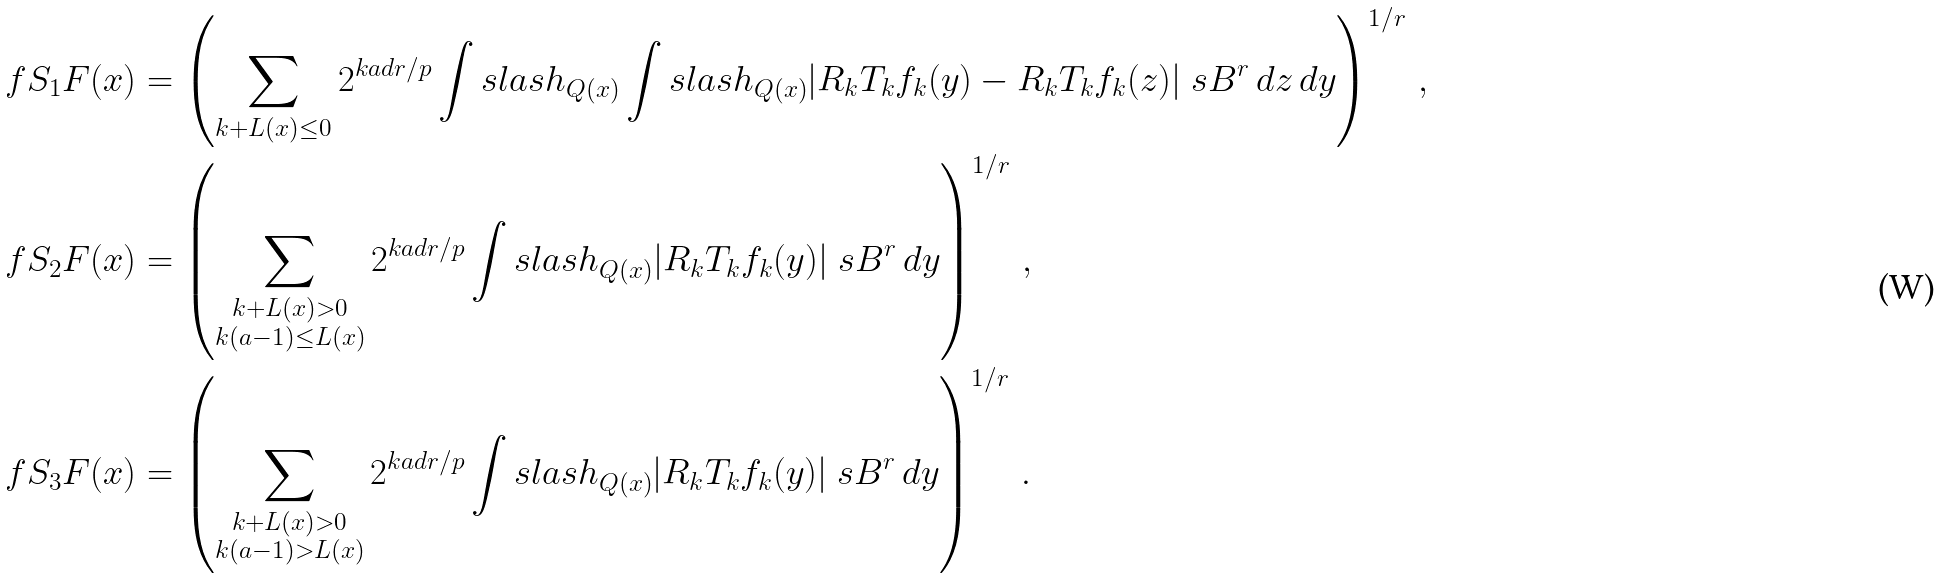Convert formula to latex. <formula><loc_0><loc_0><loc_500><loc_500>\ f S _ { 1 } F ( x ) & = \left ( \sum _ { k + L ( x ) \leq 0 } 2 ^ { k a d r / p } \int s l a s h _ { Q ( x ) } \int s l a s h _ { Q ( x ) } | R _ { k } T _ { k } f _ { k } ( y ) - R _ { k } T _ { k } f _ { k } ( z ) | _ { \ } s B ^ { r } \, d z \, d y \right ) ^ { 1 / r } \, , \\ \ f S _ { 2 } F ( x ) & = \left ( \sum _ { \substack { k + L ( x ) > 0 \\ k ( a - 1 ) \leq L ( x ) } } 2 ^ { k a d r / p } \int s l a s h _ { Q ( x ) } | R _ { k } T _ { k } f _ { k } ( y ) | _ { \ } s B ^ { r } \, d y \right ) ^ { 1 / r } \, , \\ \ f S _ { 3 } F ( x ) & = \left ( \sum _ { \substack { k + L ( x ) > 0 \\ k ( a - 1 ) > L ( x ) } } 2 ^ { k a d r / p } \int s l a s h _ { Q ( x ) } | R _ { k } T _ { k } f _ { k } ( y ) | _ { \ } s B ^ { r } \, d y \right ) ^ { 1 / r } \, .</formula> 